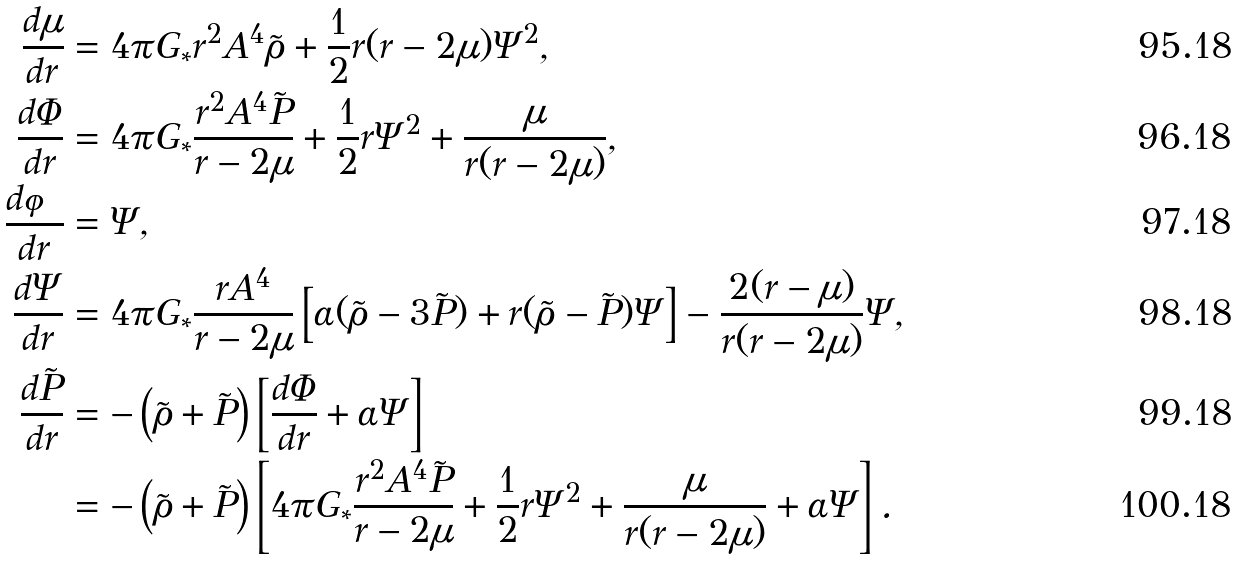Convert formula to latex. <formula><loc_0><loc_0><loc_500><loc_500>\frac { d \mu } { d r } & = 4 \pi G _ { * } r ^ { 2 } A ^ { 4 } \tilde { \rho } + \frac { 1 } { 2 } r ( r - 2 \mu ) \Psi ^ { 2 } , \\ \frac { d \Phi } { d r } & = 4 \pi G _ { * } \frac { r ^ { 2 } A ^ { 4 } \tilde { P } } { r - 2 \mu } + \frac { 1 } { 2 } r \Psi ^ { 2 } + \frac { \mu } { r ( r - 2 \mu ) } , \\ \frac { d \varphi } { d r } & = \Psi , \\ \frac { d \Psi } { d r } & = 4 \pi G _ { * } \frac { r A ^ { 4 } } { r - 2 \mu } \left [ \alpha ( \tilde { \rho } - 3 \tilde { P } ) + r ( \tilde { \rho } - \tilde { P } ) \Psi \right ] - \frac { 2 ( r - \mu ) } { r ( r - 2 \mu ) } \Psi , \\ \frac { d \tilde { P } } { d r } & = - \left ( \tilde { \rho } + \tilde { P } \right ) \left [ \frac { d \Phi } { d r } + \alpha \Psi \right ] \\ & = - \left ( \tilde { \rho } + \tilde { P } \right ) \left [ 4 \pi G _ { * } \frac { r ^ { 2 } A ^ { 4 } \tilde { P } } { r - 2 \mu } + \frac { 1 } { 2 } r \Psi ^ { 2 } + \frac { \mu } { r ( r - 2 \mu ) } + \alpha \Psi \right ] .</formula> 